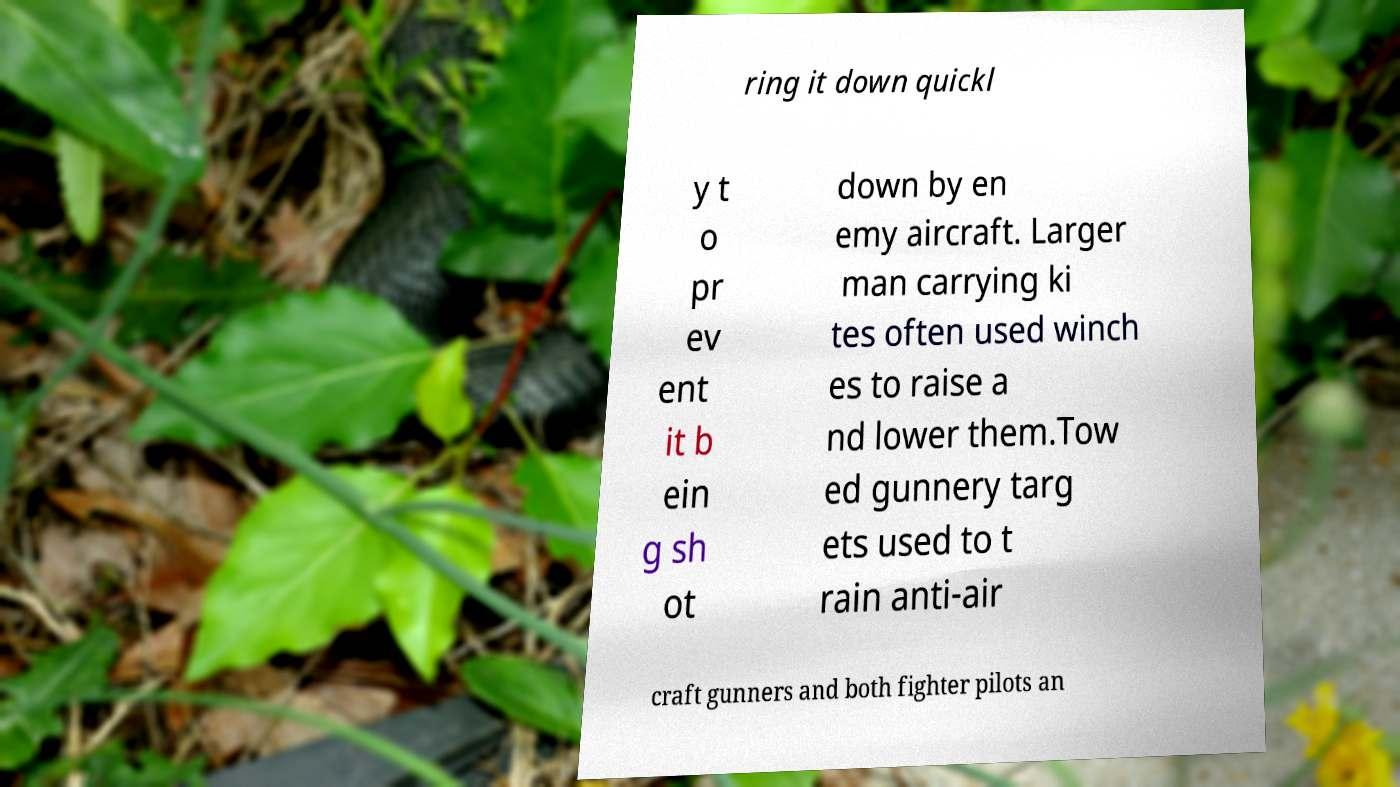There's text embedded in this image that I need extracted. Can you transcribe it verbatim? ring it down quickl y t o pr ev ent it b ein g sh ot down by en emy aircraft. Larger man carrying ki tes often used winch es to raise a nd lower them.Tow ed gunnery targ ets used to t rain anti-air craft gunners and both fighter pilots an 